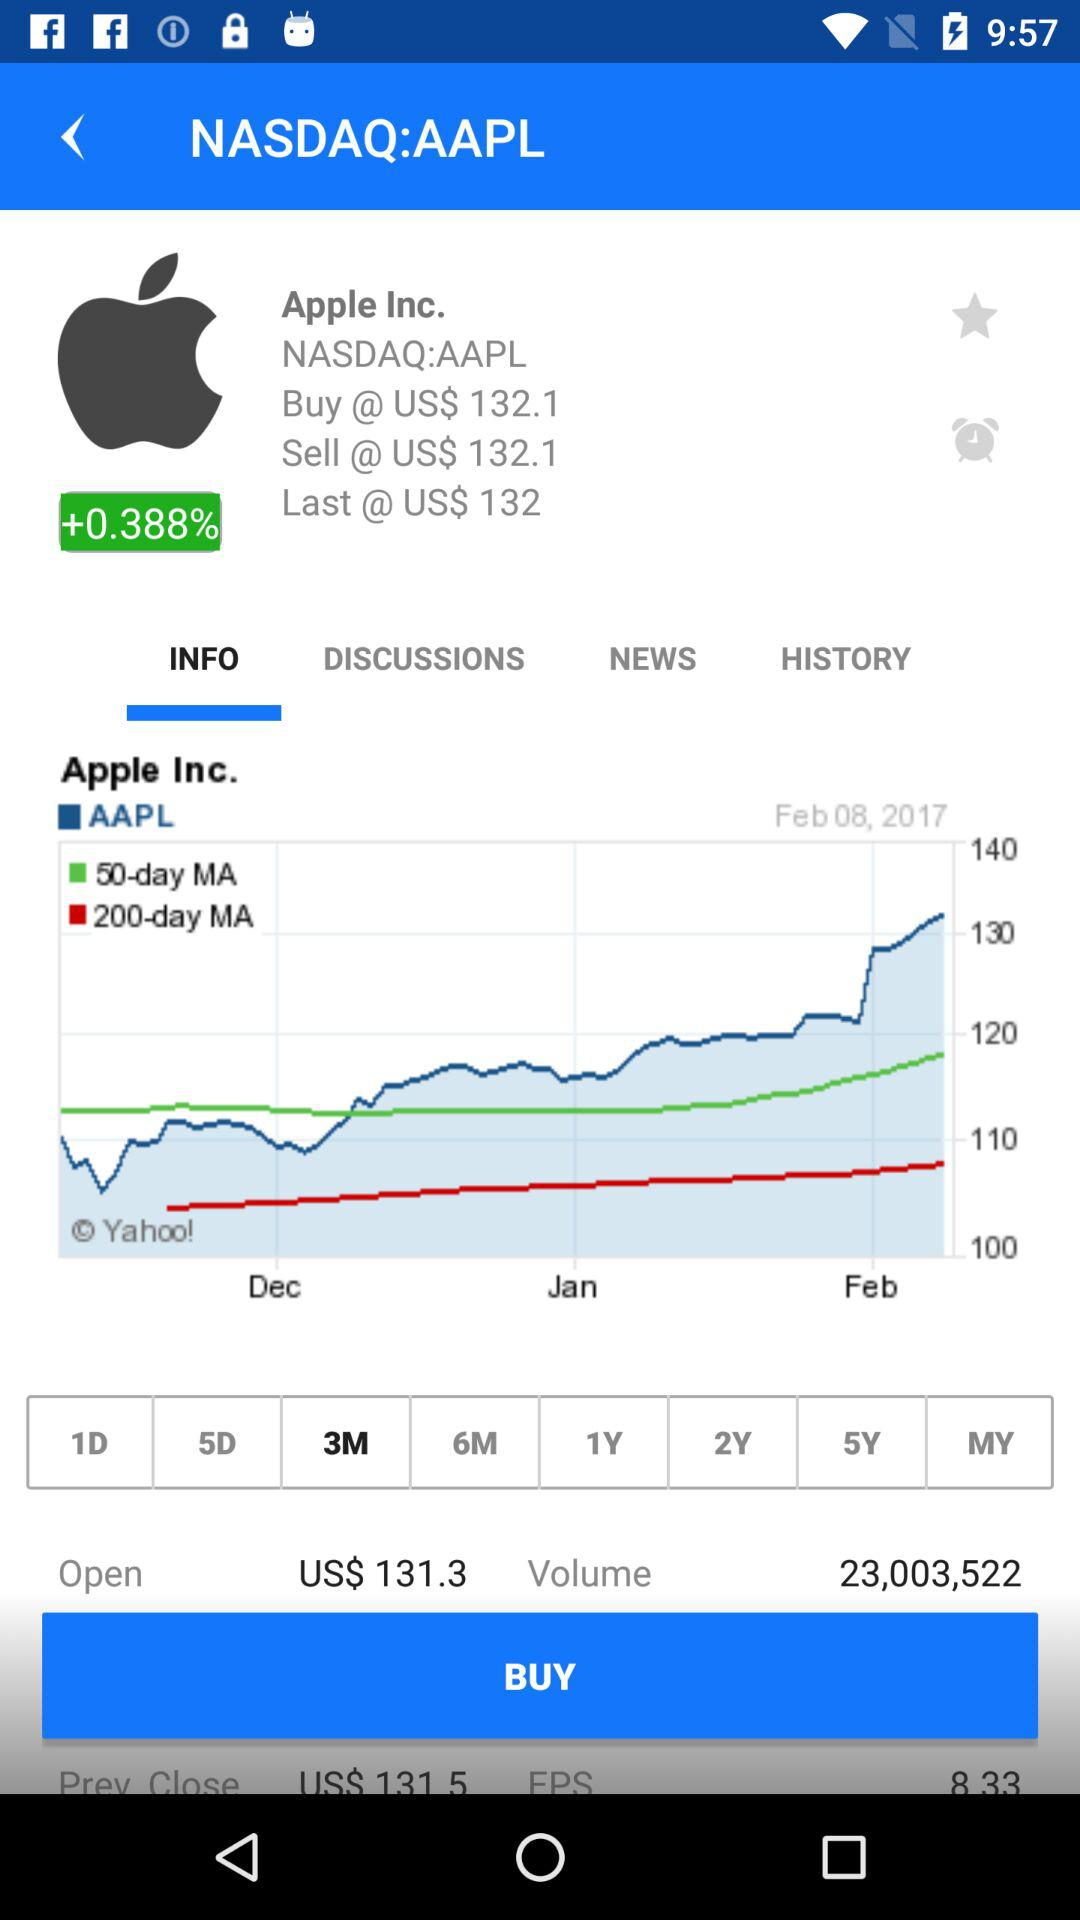What is the current price of Apple Inc. stock?
Answer the question using a single word or phrase. US$ 132.1 